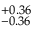Convert formula to latex. <formula><loc_0><loc_0><loc_500><loc_500>^ { + 0 . 3 6 } _ { - 0 . 3 6 }</formula> 